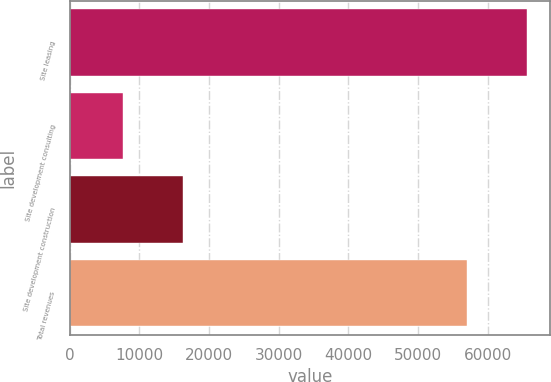Convert chart. <chart><loc_0><loc_0><loc_500><loc_500><bar_chart><fcel>Site leasing<fcel>Site development consulting<fcel>Site development construction<fcel>Total revenues<nl><fcel>65648<fcel>7689<fcel>16238<fcel>57099<nl></chart> 